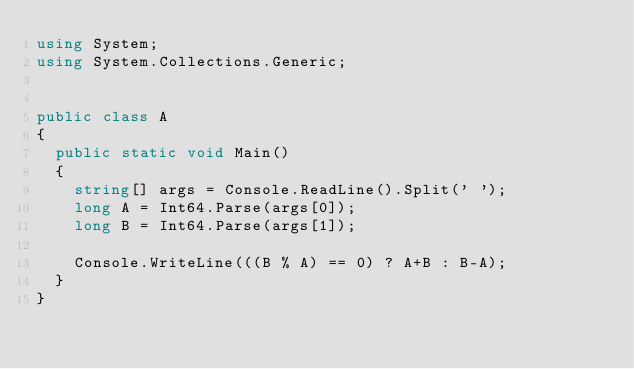Convert code to text. <code><loc_0><loc_0><loc_500><loc_500><_C#_>using System;
using System.Collections.Generic;


public class A
{
	public static void Main()
	{
		string[] args = Console.ReadLine().Split(' ');
		long A = Int64.Parse(args[0]);
		long B = Int64.Parse(args[1]);
			
		Console.WriteLine(((B % A) == 0) ? A+B : B-A);
	}	
}</code> 